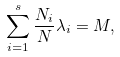<formula> <loc_0><loc_0><loc_500><loc_500>\sum ^ { s } _ { i = 1 } \frac { N _ { i } } { N } \lambda _ { i } = M ,</formula> 